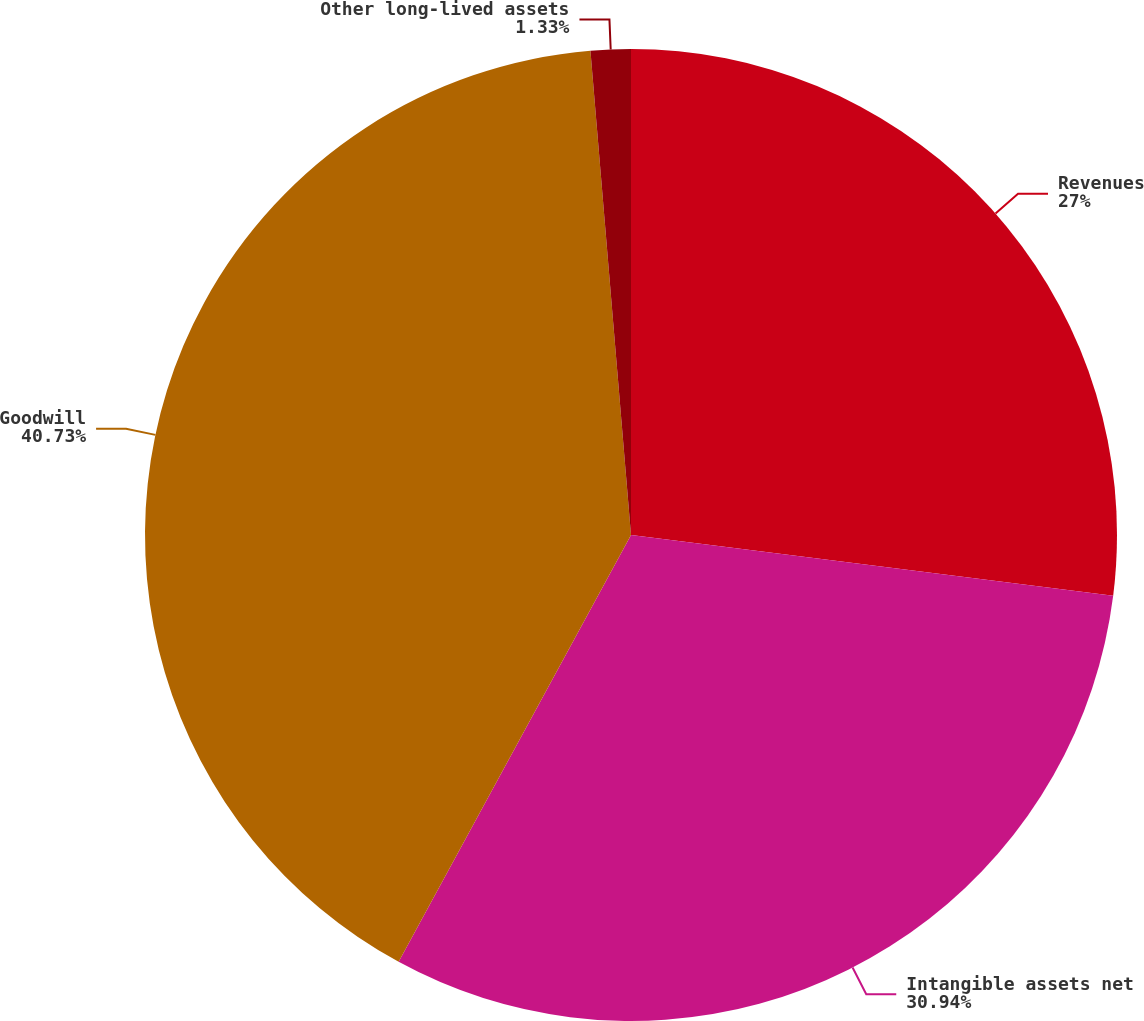<chart> <loc_0><loc_0><loc_500><loc_500><pie_chart><fcel>Revenues<fcel>Intangible assets net<fcel>Goodwill<fcel>Other long-lived assets<nl><fcel>27.0%<fcel>30.94%<fcel>40.74%<fcel>1.33%<nl></chart> 